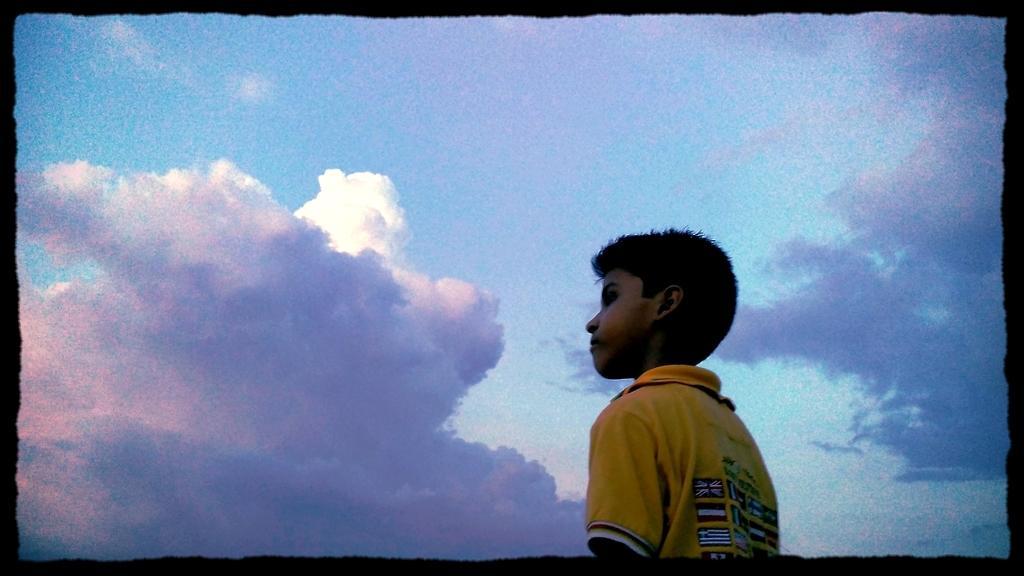Could you give a brief overview of what you see in this image? In the foreground of this image, there is a boy in yellow t-shirt. In the background, there is the sky and also there is a black border to this image. 